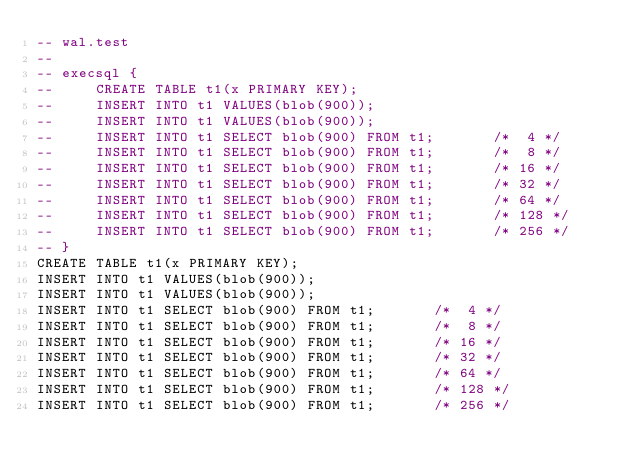Convert code to text. <code><loc_0><loc_0><loc_500><loc_500><_SQL_>-- wal.test
-- 
-- execsql {
--     CREATE TABLE t1(x PRIMARY KEY);
--     INSERT INTO t1 VALUES(blob(900));
--     INSERT INTO t1 VALUES(blob(900));
--     INSERT INTO t1 SELECT blob(900) FROM t1;       /*  4 */
--     INSERT INTO t1 SELECT blob(900) FROM t1;       /*  8 */
--     INSERT INTO t1 SELECT blob(900) FROM t1;       /* 16 */
--     INSERT INTO t1 SELECT blob(900) FROM t1;       /* 32 */
--     INSERT INTO t1 SELECT blob(900) FROM t1;       /* 64 */
--     INSERT INTO t1 SELECT blob(900) FROM t1;       /* 128 */
--     INSERT INTO t1 SELECT blob(900) FROM t1;       /* 256 */
-- }
CREATE TABLE t1(x PRIMARY KEY);
INSERT INTO t1 VALUES(blob(900));
INSERT INTO t1 VALUES(blob(900));
INSERT INTO t1 SELECT blob(900) FROM t1;       /*  4 */
INSERT INTO t1 SELECT blob(900) FROM t1;       /*  8 */
INSERT INTO t1 SELECT blob(900) FROM t1;       /* 16 */
INSERT INTO t1 SELECT blob(900) FROM t1;       /* 32 */
INSERT INTO t1 SELECT blob(900) FROM t1;       /* 64 */
INSERT INTO t1 SELECT blob(900) FROM t1;       /* 128 */
INSERT INTO t1 SELECT blob(900) FROM t1;       /* 256 */</code> 